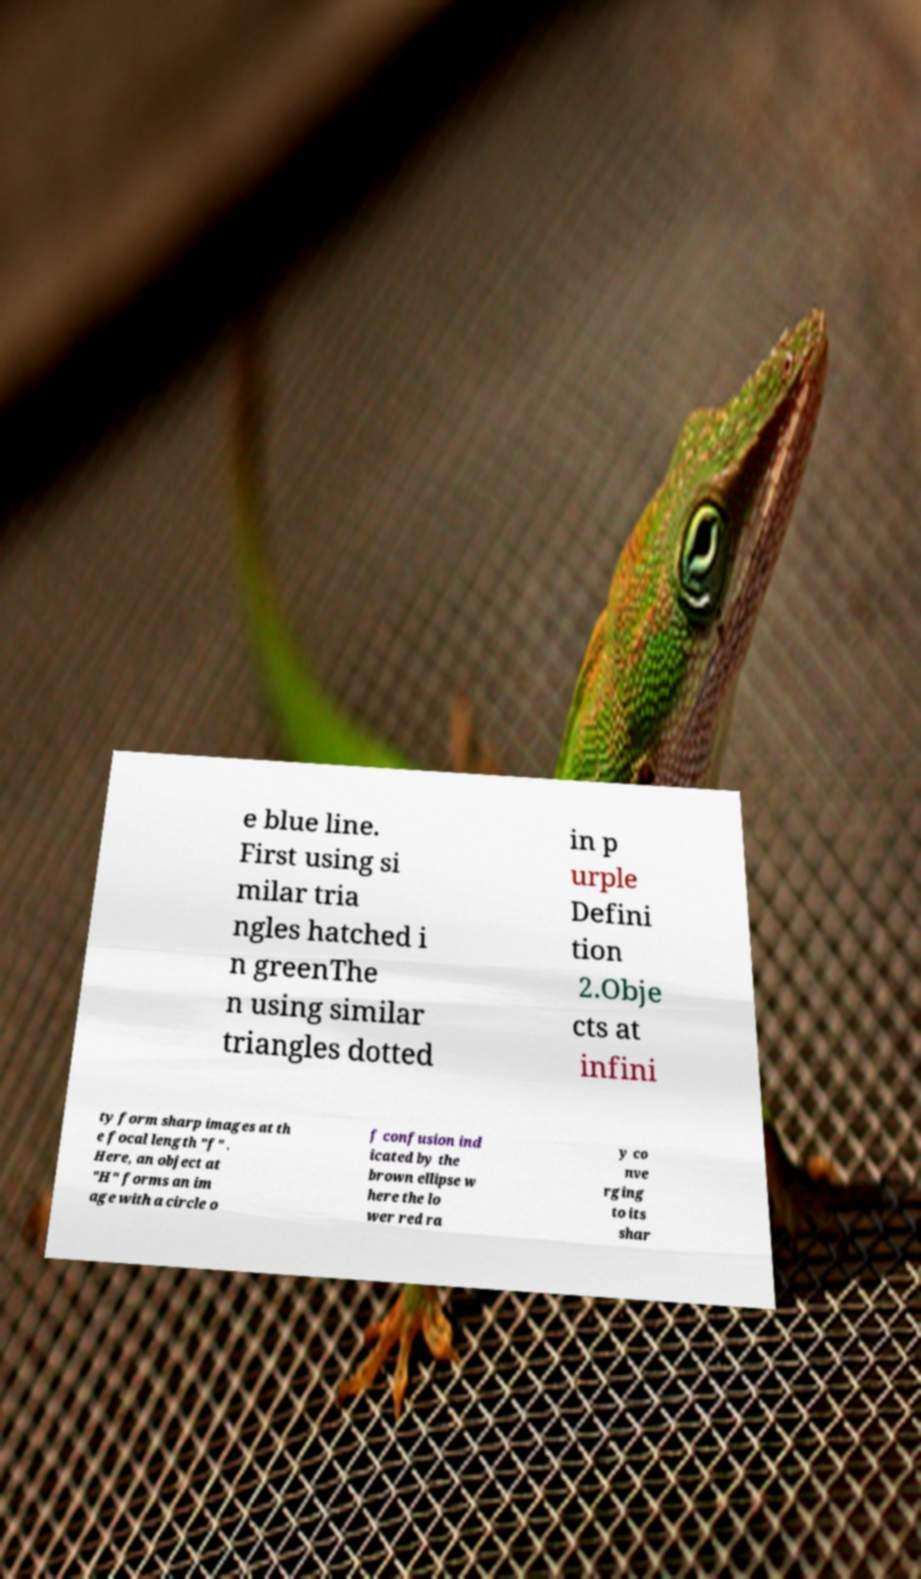For documentation purposes, I need the text within this image transcribed. Could you provide that? e blue line. First using si milar tria ngles hatched i n greenThe n using similar triangles dotted in p urple Defini tion 2.Obje cts at infini ty form sharp images at th e focal length "f" . Here, an object at "H" forms an im age with a circle o f confusion ind icated by the brown ellipse w here the lo wer red ra y co nve rging to its shar 